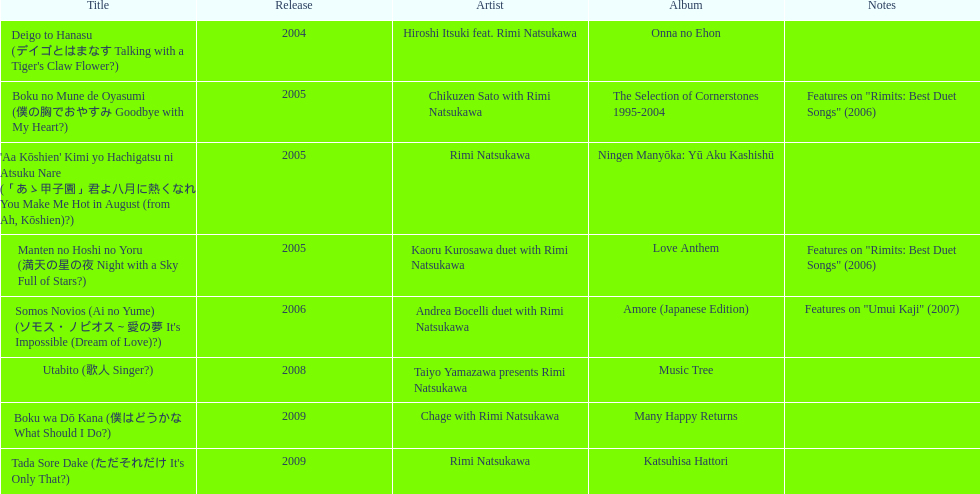During 2005, in how many events did this artist participate other than this one? 3. 